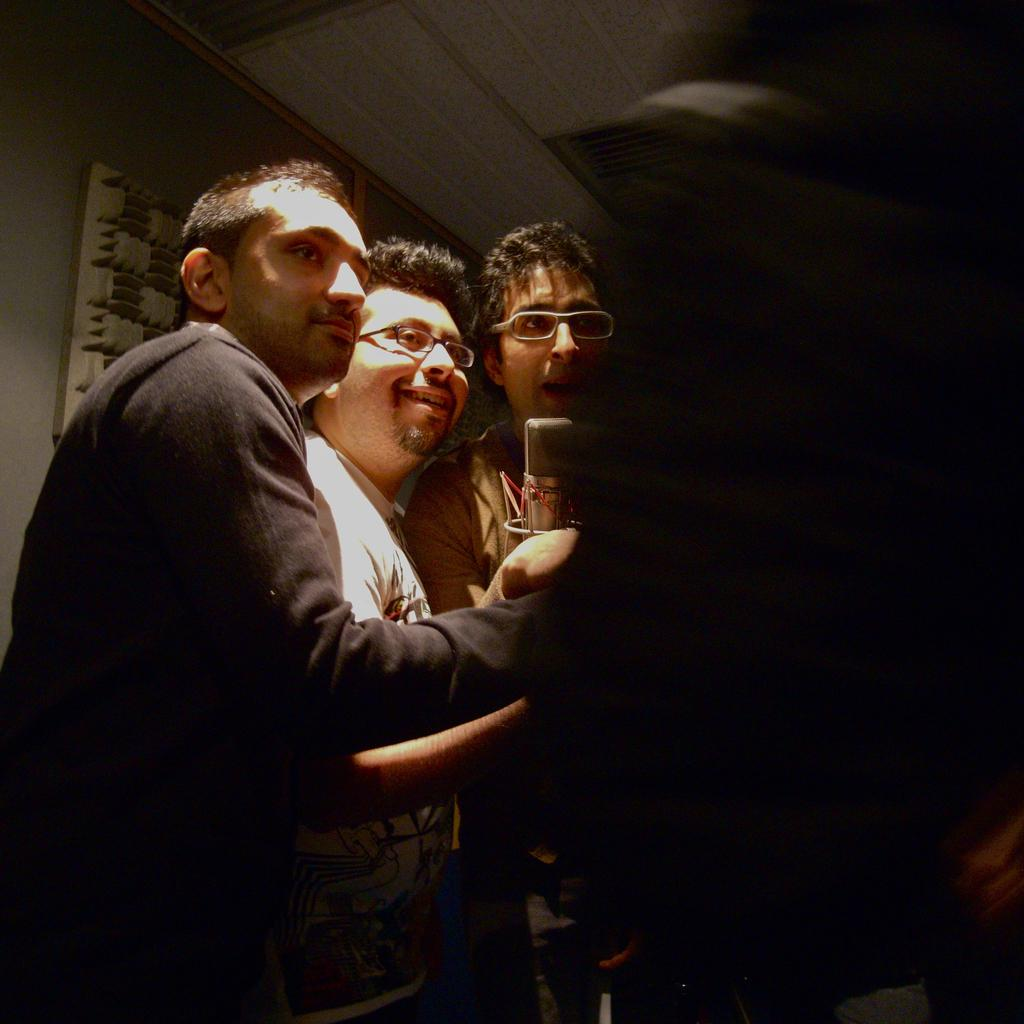What are the people in the image doing? The people in the image are standing in the center. What object is placed in front of the people? There is a mic placed before the people. What can be seen in the background of the image? There is a wall in the background of the image. What type of building is depicted in the image? There is no building depicted in the image; it only shows people standing in the center with a mic and a wall in the background. What nation are the people in the image representing? The image does not provide any information about the nationality or representation of the people. 